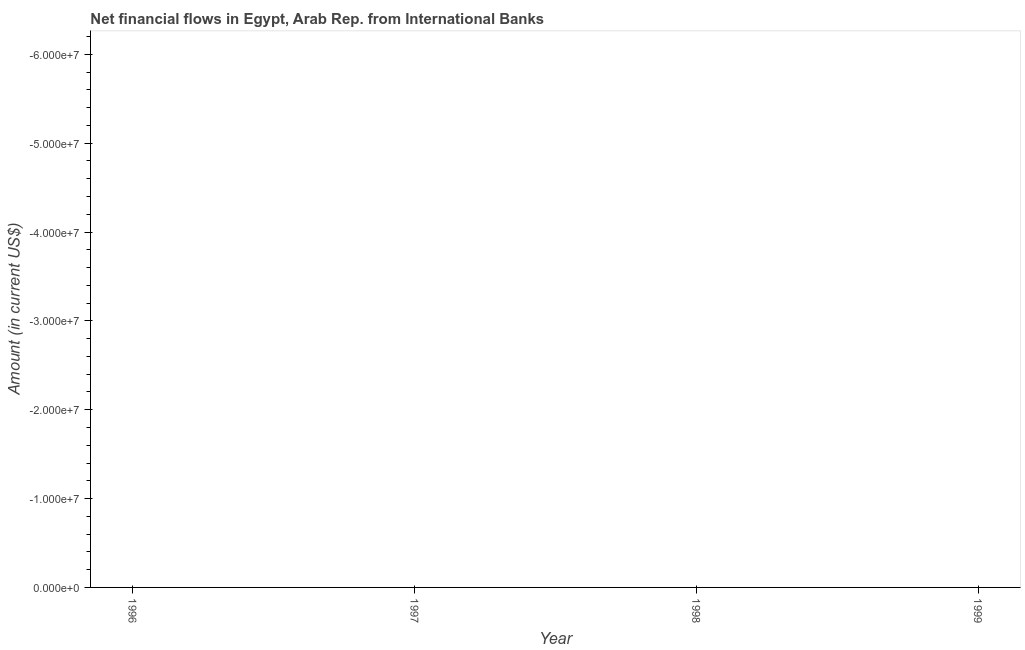What is the net financial flows from ibrd in 1999?
Offer a terse response. 0. Across all years, what is the minimum net financial flows from ibrd?
Keep it short and to the point. 0. What is the average net financial flows from ibrd per year?
Ensure brevity in your answer.  0. In how many years, is the net financial flows from ibrd greater than -34000000 US$?
Offer a terse response. 0. In how many years, is the net financial flows from ibrd greater than the average net financial flows from ibrd taken over all years?
Provide a short and direct response. 0. How many years are there in the graph?
Offer a very short reply. 4. What is the difference between two consecutive major ticks on the Y-axis?
Offer a terse response. 1.00e+07. What is the title of the graph?
Your response must be concise. Net financial flows in Egypt, Arab Rep. from International Banks. What is the label or title of the X-axis?
Provide a short and direct response. Year. What is the label or title of the Y-axis?
Give a very brief answer. Amount (in current US$). What is the Amount (in current US$) in 1996?
Offer a very short reply. 0. What is the Amount (in current US$) in 1998?
Provide a short and direct response. 0. What is the Amount (in current US$) in 1999?
Make the answer very short. 0. 